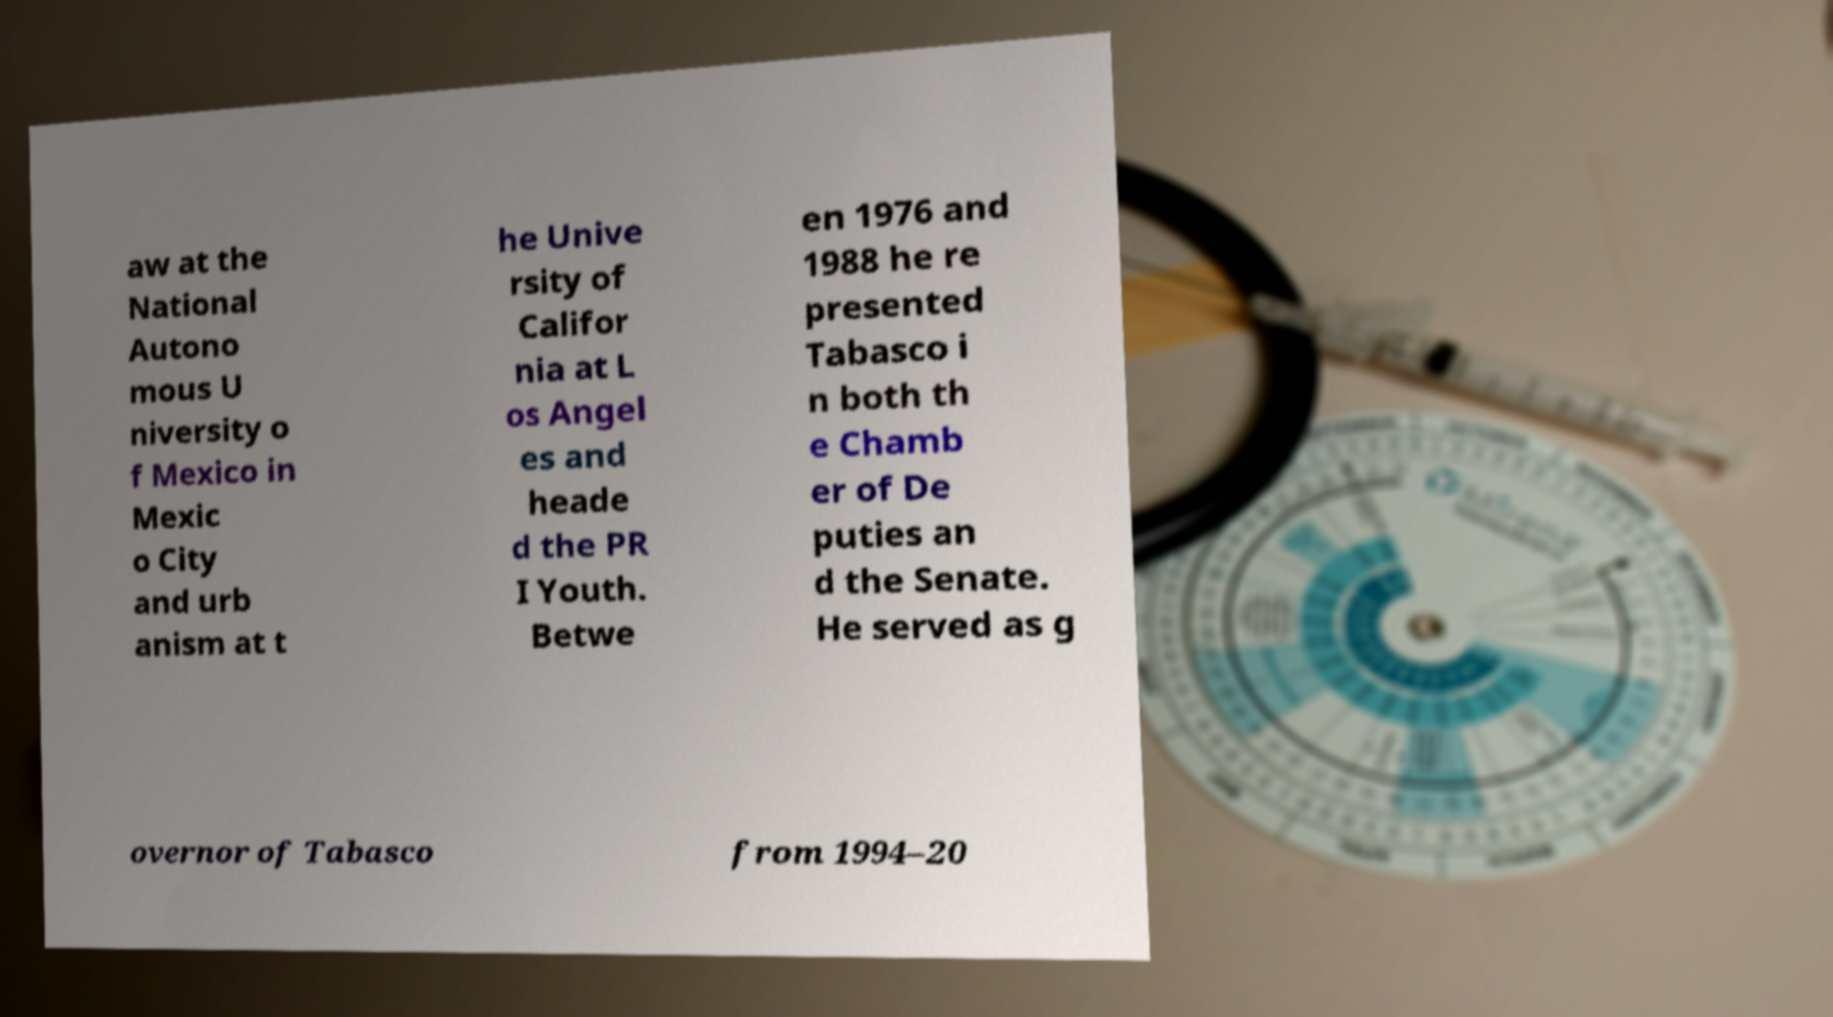For documentation purposes, I need the text within this image transcribed. Could you provide that? aw at the National Autono mous U niversity o f Mexico in Mexic o City and urb anism at t he Unive rsity of Califor nia at L os Angel es and heade d the PR I Youth. Betwe en 1976 and 1988 he re presented Tabasco i n both th e Chamb er of De puties an d the Senate. He served as g overnor of Tabasco from 1994–20 